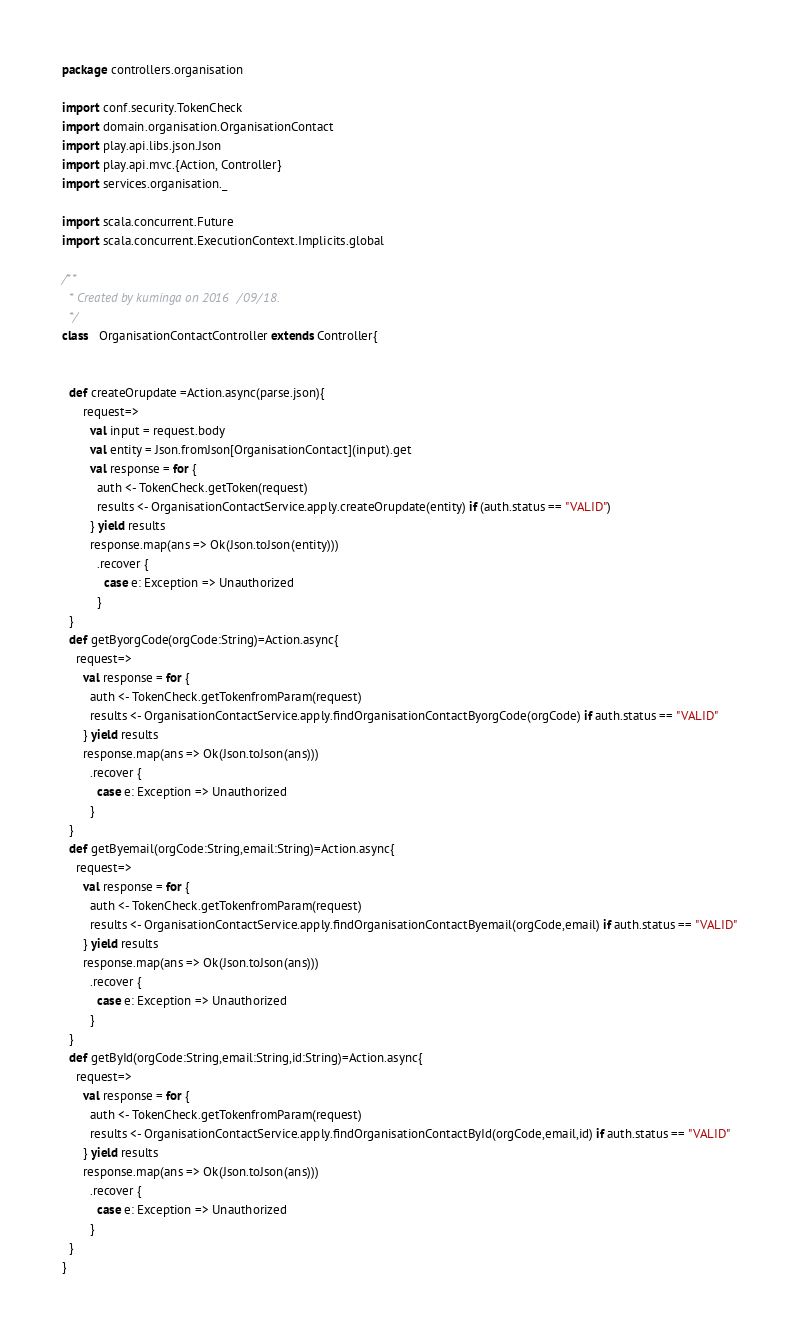<code> <loc_0><loc_0><loc_500><loc_500><_Scala_>package controllers.organisation

import conf.security.TokenCheck
import domain.organisation.OrganisationContact
import play.api.libs.json.Json
import play.api.mvc.{Action, Controller}
import services.organisation._

import scala.concurrent.Future
import scala.concurrent.ExecutionContext.Implicits.global

/**
  * Created by kuminga on 2016/09/18.
  */
class   OrganisationContactController extends Controller{


  def createOrupdate =Action.async(parse.json){
      request=>
        val input = request.body
        val entity = Json.fromJson[OrganisationContact](input).get
        val response = for {
          auth <- TokenCheck.getToken(request)
          results <- OrganisationContactService.apply.createOrupdate(entity) if (auth.status == "VALID")
        } yield results
        response.map(ans => Ok(Json.toJson(entity)))
          .recover {
            case e: Exception => Unauthorized
          }
  }
  def getByorgCode(orgCode:String)=Action.async{
    request=>
      val response = for {
        auth <- TokenCheck.getTokenfromParam(request)
        results <- OrganisationContactService.apply.findOrganisationContactByorgCode(orgCode) if auth.status == "VALID"
      } yield results
      response.map(ans => Ok(Json.toJson(ans)))
        .recover {
          case e: Exception => Unauthorized
        }
  }
  def getByemail(orgCode:String,email:String)=Action.async{
    request=>
      val response = for {
        auth <- TokenCheck.getTokenfromParam(request)
        results <- OrganisationContactService.apply.findOrganisationContactByemail(orgCode,email) if auth.status == "VALID"
      } yield results
      response.map(ans => Ok(Json.toJson(ans)))
        .recover {
          case e: Exception => Unauthorized
        }
  }
  def getById(orgCode:String,email:String,id:String)=Action.async{
    request=>
      val response = for {
        auth <- TokenCheck.getTokenfromParam(request)
        results <- OrganisationContactService.apply.findOrganisationContactById(orgCode,email,id) if auth.status == "VALID"
      } yield results
      response.map(ans => Ok(Json.toJson(ans)))
        .recover {
          case e: Exception => Unauthorized
        }
  }
}
</code> 